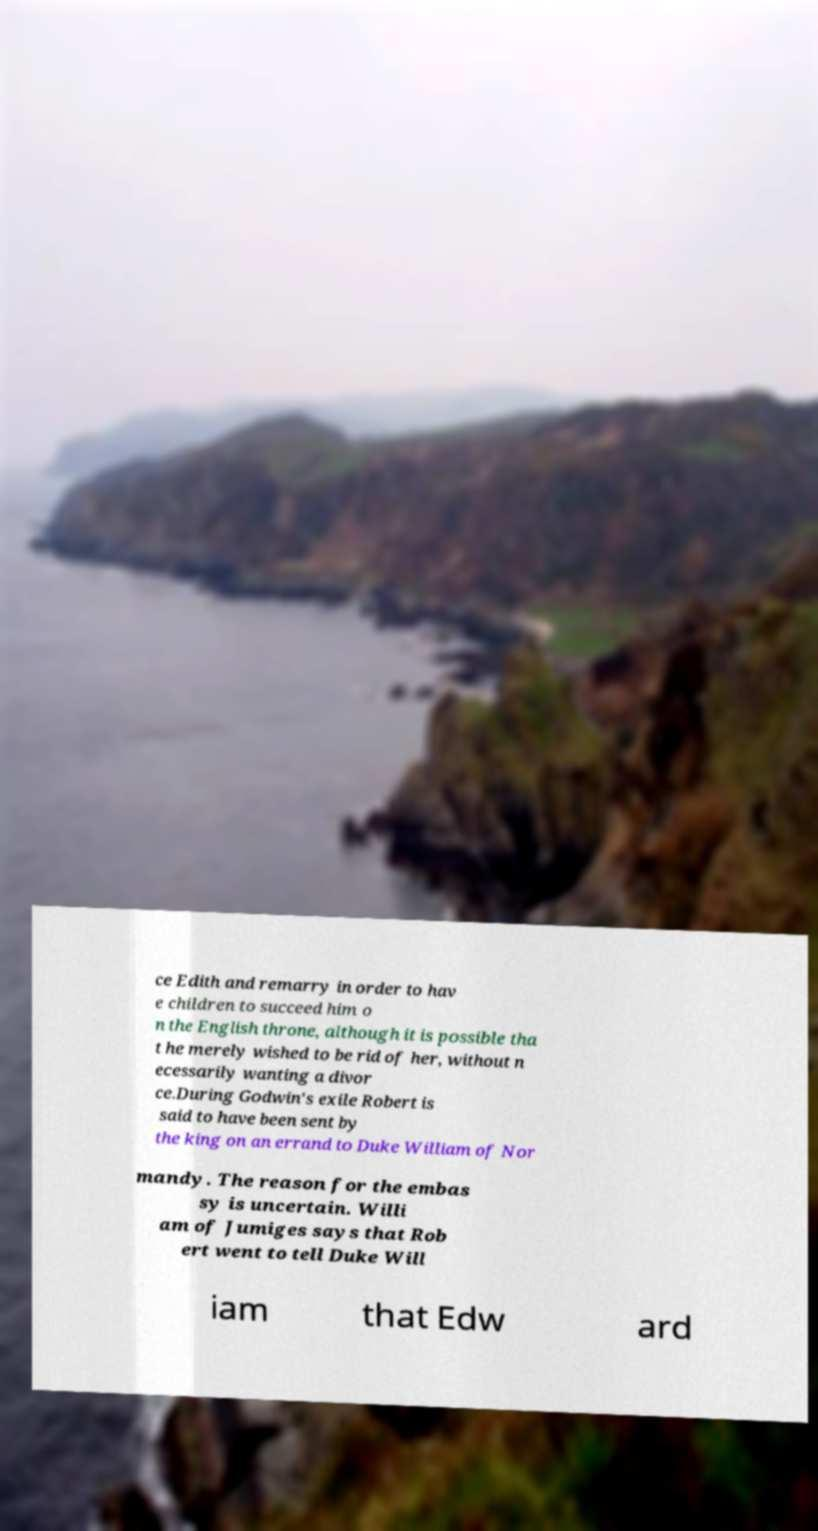Could you extract and type out the text from this image? ce Edith and remarry in order to hav e children to succeed him o n the English throne, although it is possible tha t he merely wished to be rid of her, without n ecessarily wanting a divor ce.During Godwin's exile Robert is said to have been sent by the king on an errand to Duke William of Nor mandy. The reason for the embas sy is uncertain. Willi am of Jumiges says that Rob ert went to tell Duke Will iam that Edw ard 